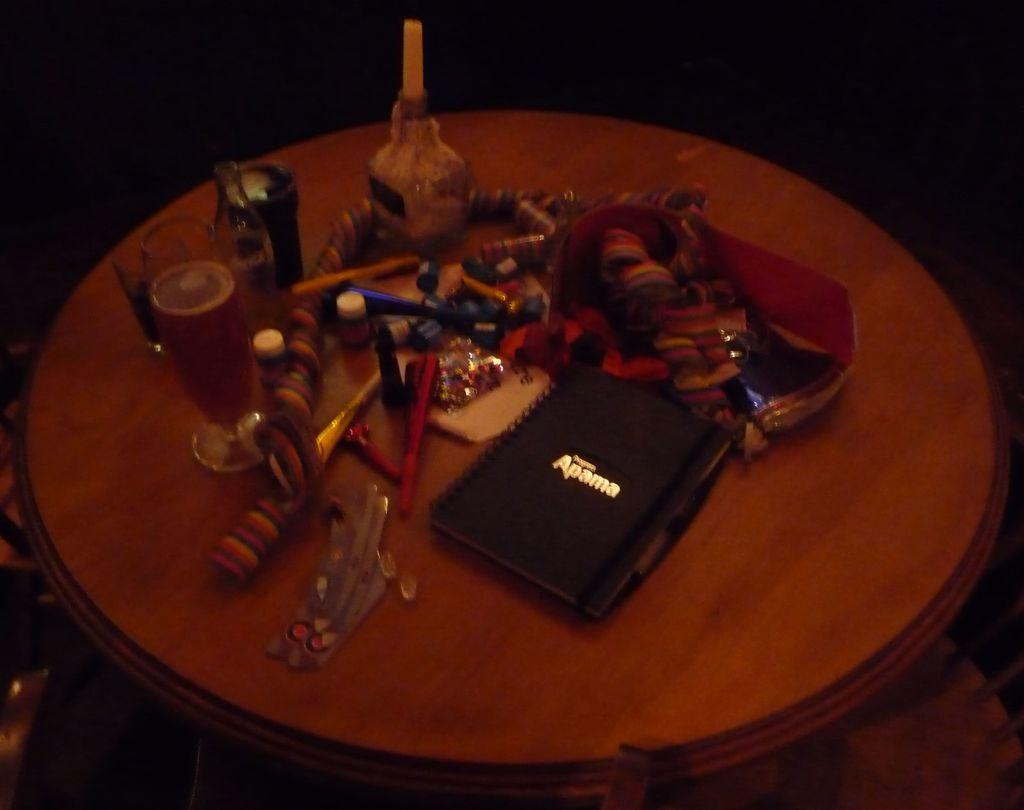<image>
Give a short and clear explanation of the subsequent image. A round wooden table has beer on it and a notebook that says Apama. 